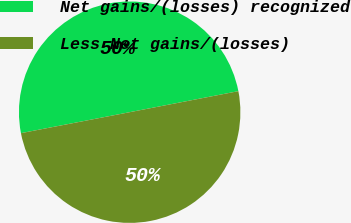Convert chart to OTSL. <chart><loc_0><loc_0><loc_500><loc_500><pie_chart><fcel>Net gains/(losses) recognized<fcel>Less Net gains/(losses)<nl><fcel>49.99%<fcel>50.01%<nl></chart> 